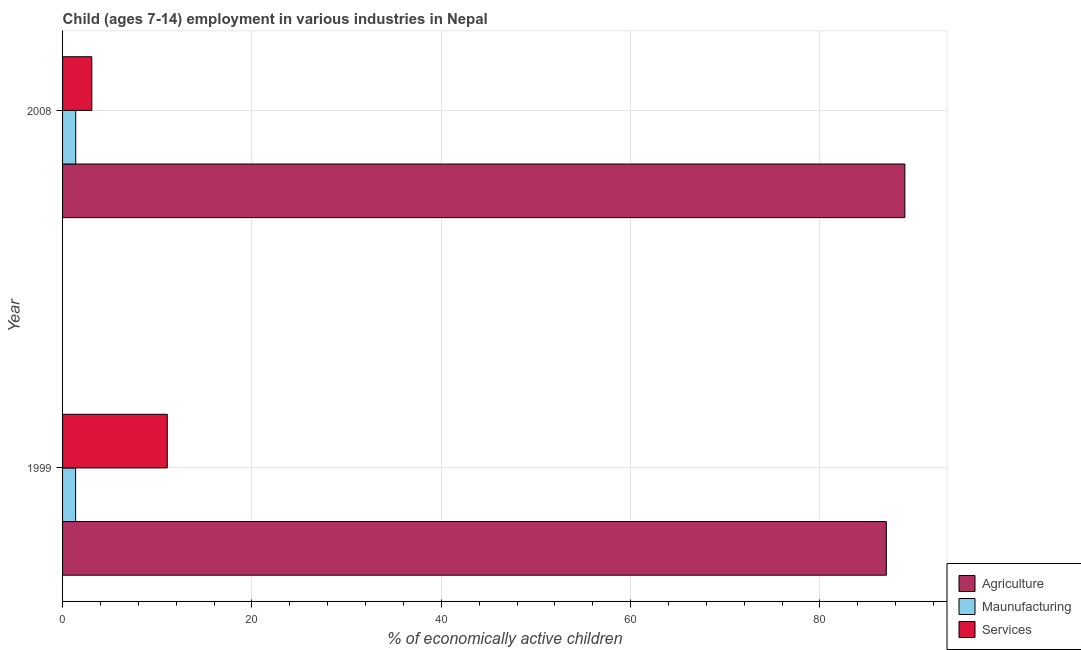How many different coloured bars are there?
Your response must be concise. 3. Are the number of bars per tick equal to the number of legend labels?
Your answer should be very brief. Yes. How many bars are there on the 2nd tick from the bottom?
Provide a succinct answer. 3. What is the label of the 1st group of bars from the top?
Keep it short and to the point. 2008. In how many cases, is the number of bars for a given year not equal to the number of legend labels?
Your answer should be compact. 0. What is the percentage of economically active children in manufacturing in 1999?
Ensure brevity in your answer.  1.38. Across all years, what is the maximum percentage of economically active children in agriculture?
Make the answer very short. 88.97. Across all years, what is the minimum percentage of economically active children in manufacturing?
Give a very brief answer. 1.38. In which year was the percentage of economically active children in services maximum?
Provide a short and direct response. 1999. What is the total percentage of economically active children in services in the graph?
Your answer should be very brief. 14.15. What is the difference between the percentage of economically active children in services in 1999 and that in 2008?
Give a very brief answer. 7.97. What is the difference between the percentage of economically active children in services in 2008 and the percentage of economically active children in agriculture in 1999?
Give a very brief answer. -83.92. What is the average percentage of economically active children in services per year?
Offer a terse response. 7.08. What is the ratio of the percentage of economically active children in services in 1999 to that in 2008?
Keep it short and to the point. 3.58. In how many years, is the percentage of economically active children in agriculture greater than the average percentage of economically active children in agriculture taken over all years?
Make the answer very short. 1. What does the 1st bar from the top in 2008 represents?
Ensure brevity in your answer.  Services. What does the 1st bar from the bottom in 2008 represents?
Make the answer very short. Agriculture. Is it the case that in every year, the sum of the percentage of economically active children in agriculture and percentage of economically active children in manufacturing is greater than the percentage of economically active children in services?
Your answer should be very brief. Yes. How many bars are there?
Your answer should be compact. 6. Are all the bars in the graph horizontal?
Provide a short and direct response. Yes. How many years are there in the graph?
Your response must be concise. 2. What is the difference between two consecutive major ticks on the X-axis?
Your answer should be compact. 20. Are the values on the major ticks of X-axis written in scientific E-notation?
Offer a very short reply. No. Does the graph contain grids?
Your response must be concise. Yes. Where does the legend appear in the graph?
Your answer should be compact. Bottom right. How are the legend labels stacked?
Make the answer very short. Vertical. What is the title of the graph?
Offer a very short reply. Child (ages 7-14) employment in various industries in Nepal. What is the label or title of the X-axis?
Your response must be concise. % of economically active children. What is the % of economically active children in Agriculture in 1999?
Keep it short and to the point. 87.01. What is the % of economically active children of Maunufacturing in 1999?
Ensure brevity in your answer.  1.38. What is the % of economically active children of Services in 1999?
Your answer should be very brief. 11.06. What is the % of economically active children of Agriculture in 2008?
Provide a short and direct response. 88.97. What is the % of economically active children of Maunufacturing in 2008?
Provide a succinct answer. 1.39. What is the % of economically active children in Services in 2008?
Provide a succinct answer. 3.09. Across all years, what is the maximum % of economically active children in Agriculture?
Provide a succinct answer. 88.97. Across all years, what is the maximum % of economically active children in Maunufacturing?
Provide a short and direct response. 1.39. Across all years, what is the maximum % of economically active children in Services?
Offer a terse response. 11.06. Across all years, what is the minimum % of economically active children in Agriculture?
Give a very brief answer. 87.01. Across all years, what is the minimum % of economically active children in Maunufacturing?
Your answer should be very brief. 1.38. Across all years, what is the minimum % of economically active children of Services?
Provide a succinct answer. 3.09. What is the total % of economically active children of Agriculture in the graph?
Offer a terse response. 175.98. What is the total % of economically active children of Maunufacturing in the graph?
Ensure brevity in your answer.  2.77. What is the total % of economically active children of Services in the graph?
Provide a short and direct response. 14.15. What is the difference between the % of economically active children in Agriculture in 1999 and that in 2008?
Keep it short and to the point. -1.96. What is the difference between the % of economically active children in Maunufacturing in 1999 and that in 2008?
Offer a terse response. -0.01. What is the difference between the % of economically active children in Services in 1999 and that in 2008?
Ensure brevity in your answer.  7.97. What is the difference between the % of economically active children of Agriculture in 1999 and the % of economically active children of Maunufacturing in 2008?
Your answer should be very brief. 85.62. What is the difference between the % of economically active children in Agriculture in 1999 and the % of economically active children in Services in 2008?
Your answer should be compact. 83.92. What is the difference between the % of economically active children in Maunufacturing in 1999 and the % of economically active children in Services in 2008?
Offer a terse response. -1.71. What is the average % of economically active children in Agriculture per year?
Ensure brevity in your answer.  87.99. What is the average % of economically active children in Maunufacturing per year?
Keep it short and to the point. 1.39. What is the average % of economically active children of Services per year?
Give a very brief answer. 7.08. In the year 1999, what is the difference between the % of economically active children in Agriculture and % of economically active children in Maunufacturing?
Provide a short and direct response. 85.63. In the year 1999, what is the difference between the % of economically active children of Agriculture and % of economically active children of Services?
Offer a terse response. 75.95. In the year 1999, what is the difference between the % of economically active children of Maunufacturing and % of economically active children of Services?
Ensure brevity in your answer.  -9.68. In the year 2008, what is the difference between the % of economically active children of Agriculture and % of economically active children of Maunufacturing?
Offer a terse response. 87.58. In the year 2008, what is the difference between the % of economically active children of Agriculture and % of economically active children of Services?
Offer a very short reply. 85.88. In the year 2008, what is the difference between the % of economically active children of Maunufacturing and % of economically active children of Services?
Your answer should be compact. -1.7. What is the ratio of the % of economically active children in Maunufacturing in 1999 to that in 2008?
Keep it short and to the point. 0.99. What is the ratio of the % of economically active children of Services in 1999 to that in 2008?
Your answer should be compact. 3.58. What is the difference between the highest and the second highest % of economically active children of Agriculture?
Give a very brief answer. 1.96. What is the difference between the highest and the second highest % of economically active children of Services?
Keep it short and to the point. 7.97. What is the difference between the highest and the lowest % of economically active children in Agriculture?
Your answer should be compact. 1.96. What is the difference between the highest and the lowest % of economically active children in Services?
Offer a very short reply. 7.97. 